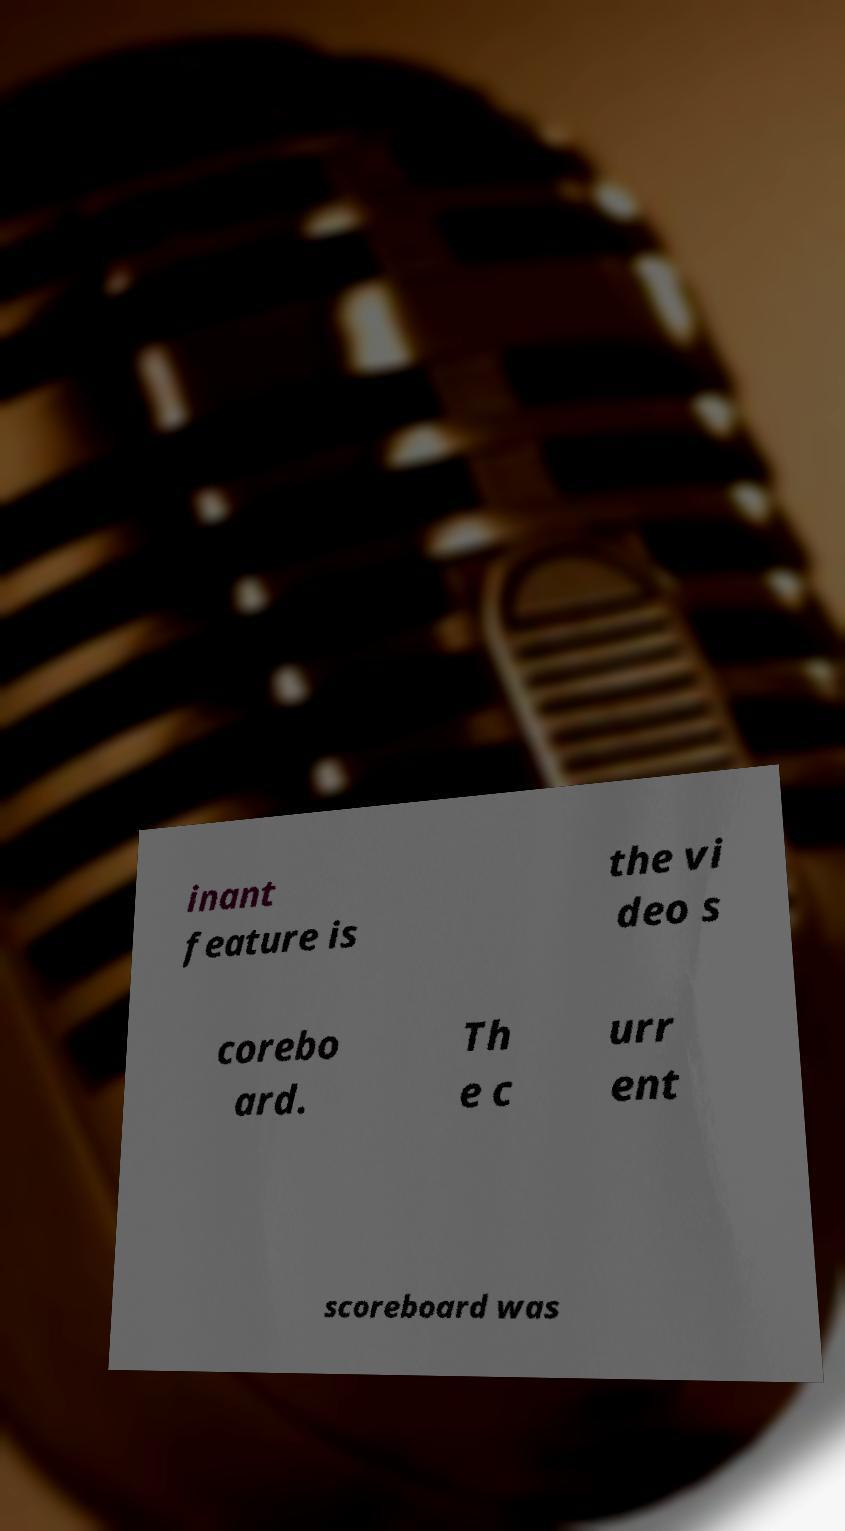What messages or text are displayed in this image? I need them in a readable, typed format. inant feature is the vi deo s corebo ard. Th e c urr ent scoreboard was 